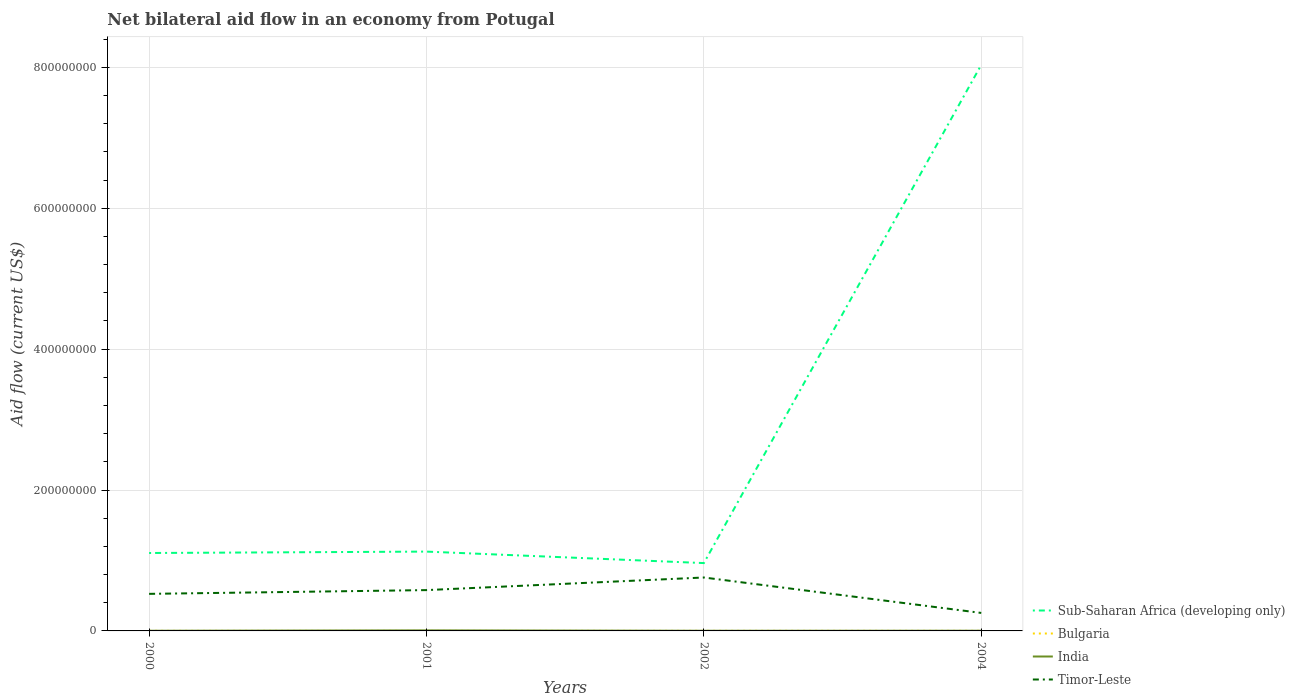How many different coloured lines are there?
Provide a succinct answer. 4. Does the line corresponding to Timor-Leste intersect with the line corresponding to Bulgaria?
Offer a terse response. No. Across all years, what is the maximum net bilateral aid flow in Sub-Saharan Africa (developing only)?
Offer a terse response. 9.63e+07. In which year was the net bilateral aid flow in Sub-Saharan Africa (developing only) maximum?
Keep it short and to the point. 2002. What is the total net bilateral aid flow in India in the graph?
Keep it short and to the point. 0. What is the difference between the highest and the second highest net bilateral aid flow in India?
Keep it short and to the point. 5.40e+05. How many years are there in the graph?
Your answer should be compact. 4. What is the difference between two consecutive major ticks on the Y-axis?
Offer a terse response. 2.00e+08. Are the values on the major ticks of Y-axis written in scientific E-notation?
Offer a terse response. No. Does the graph contain grids?
Your answer should be compact. Yes. How are the legend labels stacked?
Provide a succinct answer. Vertical. What is the title of the graph?
Your answer should be very brief. Net bilateral aid flow in an economy from Potugal. Does "Togo" appear as one of the legend labels in the graph?
Keep it short and to the point. No. What is the label or title of the Y-axis?
Keep it short and to the point. Aid flow (current US$). What is the Aid flow (current US$) of Sub-Saharan Africa (developing only) in 2000?
Keep it short and to the point. 1.11e+08. What is the Aid flow (current US$) of Bulgaria in 2000?
Offer a very short reply. 8.00e+04. What is the Aid flow (current US$) of Timor-Leste in 2000?
Provide a short and direct response. 5.26e+07. What is the Aid flow (current US$) of Sub-Saharan Africa (developing only) in 2001?
Ensure brevity in your answer.  1.13e+08. What is the Aid flow (current US$) in India in 2001?
Ensure brevity in your answer.  7.80e+05. What is the Aid flow (current US$) of Timor-Leste in 2001?
Your response must be concise. 5.80e+07. What is the Aid flow (current US$) of Sub-Saharan Africa (developing only) in 2002?
Your answer should be compact. 9.63e+07. What is the Aid flow (current US$) of Bulgaria in 2002?
Your response must be concise. 8.00e+04. What is the Aid flow (current US$) in Timor-Leste in 2002?
Your answer should be compact. 7.58e+07. What is the Aid flow (current US$) of Sub-Saharan Africa (developing only) in 2004?
Give a very brief answer. 8.04e+08. What is the Aid flow (current US$) of Bulgaria in 2004?
Your answer should be compact. 8.00e+04. What is the Aid flow (current US$) of Timor-Leste in 2004?
Your response must be concise. 2.56e+07. Across all years, what is the maximum Aid flow (current US$) in Sub-Saharan Africa (developing only)?
Offer a terse response. 8.04e+08. Across all years, what is the maximum Aid flow (current US$) in India?
Offer a terse response. 7.80e+05. Across all years, what is the maximum Aid flow (current US$) in Timor-Leste?
Offer a very short reply. 7.58e+07. Across all years, what is the minimum Aid flow (current US$) in Sub-Saharan Africa (developing only)?
Your response must be concise. 9.63e+07. Across all years, what is the minimum Aid flow (current US$) of Timor-Leste?
Your answer should be very brief. 2.56e+07. What is the total Aid flow (current US$) of Sub-Saharan Africa (developing only) in the graph?
Ensure brevity in your answer.  1.12e+09. What is the total Aid flow (current US$) of Bulgaria in the graph?
Make the answer very short. 2.70e+05. What is the total Aid flow (current US$) in India in the graph?
Provide a succinct answer. 1.55e+06. What is the total Aid flow (current US$) of Timor-Leste in the graph?
Give a very brief answer. 2.12e+08. What is the difference between the Aid flow (current US$) of Sub-Saharan Africa (developing only) in 2000 and that in 2001?
Offer a very short reply. -2.00e+06. What is the difference between the Aid flow (current US$) in India in 2000 and that in 2001?
Offer a terse response. -5.40e+05. What is the difference between the Aid flow (current US$) of Timor-Leste in 2000 and that in 2001?
Provide a short and direct response. -5.33e+06. What is the difference between the Aid flow (current US$) of Sub-Saharan Africa (developing only) in 2000 and that in 2002?
Provide a short and direct response. 1.43e+07. What is the difference between the Aid flow (current US$) in Bulgaria in 2000 and that in 2002?
Offer a very short reply. 0. What is the difference between the Aid flow (current US$) of India in 2000 and that in 2002?
Keep it short and to the point. 0. What is the difference between the Aid flow (current US$) in Timor-Leste in 2000 and that in 2002?
Provide a short and direct response. -2.32e+07. What is the difference between the Aid flow (current US$) in Sub-Saharan Africa (developing only) in 2000 and that in 2004?
Your answer should be compact. -6.93e+08. What is the difference between the Aid flow (current US$) of Bulgaria in 2000 and that in 2004?
Your answer should be very brief. 0. What is the difference between the Aid flow (current US$) of Timor-Leste in 2000 and that in 2004?
Offer a terse response. 2.71e+07. What is the difference between the Aid flow (current US$) in Sub-Saharan Africa (developing only) in 2001 and that in 2002?
Provide a succinct answer. 1.63e+07. What is the difference between the Aid flow (current US$) in India in 2001 and that in 2002?
Give a very brief answer. 5.40e+05. What is the difference between the Aid flow (current US$) in Timor-Leste in 2001 and that in 2002?
Give a very brief answer. -1.79e+07. What is the difference between the Aid flow (current US$) in Sub-Saharan Africa (developing only) in 2001 and that in 2004?
Offer a very short reply. -6.91e+08. What is the difference between the Aid flow (current US$) of India in 2001 and that in 2004?
Your answer should be very brief. 4.90e+05. What is the difference between the Aid flow (current US$) in Timor-Leste in 2001 and that in 2004?
Your answer should be compact. 3.24e+07. What is the difference between the Aid flow (current US$) of Sub-Saharan Africa (developing only) in 2002 and that in 2004?
Provide a succinct answer. -7.07e+08. What is the difference between the Aid flow (current US$) in Timor-Leste in 2002 and that in 2004?
Make the answer very short. 5.03e+07. What is the difference between the Aid flow (current US$) of Sub-Saharan Africa (developing only) in 2000 and the Aid flow (current US$) of Bulgaria in 2001?
Keep it short and to the point. 1.11e+08. What is the difference between the Aid flow (current US$) of Sub-Saharan Africa (developing only) in 2000 and the Aid flow (current US$) of India in 2001?
Offer a terse response. 1.10e+08. What is the difference between the Aid flow (current US$) of Sub-Saharan Africa (developing only) in 2000 and the Aid flow (current US$) of Timor-Leste in 2001?
Provide a short and direct response. 5.27e+07. What is the difference between the Aid flow (current US$) of Bulgaria in 2000 and the Aid flow (current US$) of India in 2001?
Make the answer very short. -7.00e+05. What is the difference between the Aid flow (current US$) in Bulgaria in 2000 and the Aid flow (current US$) in Timor-Leste in 2001?
Provide a short and direct response. -5.79e+07. What is the difference between the Aid flow (current US$) in India in 2000 and the Aid flow (current US$) in Timor-Leste in 2001?
Make the answer very short. -5.77e+07. What is the difference between the Aid flow (current US$) in Sub-Saharan Africa (developing only) in 2000 and the Aid flow (current US$) in Bulgaria in 2002?
Your response must be concise. 1.11e+08. What is the difference between the Aid flow (current US$) of Sub-Saharan Africa (developing only) in 2000 and the Aid flow (current US$) of India in 2002?
Provide a succinct answer. 1.10e+08. What is the difference between the Aid flow (current US$) of Sub-Saharan Africa (developing only) in 2000 and the Aid flow (current US$) of Timor-Leste in 2002?
Offer a very short reply. 3.48e+07. What is the difference between the Aid flow (current US$) in Bulgaria in 2000 and the Aid flow (current US$) in India in 2002?
Ensure brevity in your answer.  -1.60e+05. What is the difference between the Aid flow (current US$) of Bulgaria in 2000 and the Aid flow (current US$) of Timor-Leste in 2002?
Provide a short and direct response. -7.58e+07. What is the difference between the Aid flow (current US$) in India in 2000 and the Aid flow (current US$) in Timor-Leste in 2002?
Provide a succinct answer. -7.56e+07. What is the difference between the Aid flow (current US$) of Sub-Saharan Africa (developing only) in 2000 and the Aid flow (current US$) of Bulgaria in 2004?
Provide a succinct answer. 1.11e+08. What is the difference between the Aid flow (current US$) of Sub-Saharan Africa (developing only) in 2000 and the Aid flow (current US$) of India in 2004?
Make the answer very short. 1.10e+08. What is the difference between the Aid flow (current US$) of Sub-Saharan Africa (developing only) in 2000 and the Aid flow (current US$) of Timor-Leste in 2004?
Ensure brevity in your answer.  8.51e+07. What is the difference between the Aid flow (current US$) in Bulgaria in 2000 and the Aid flow (current US$) in Timor-Leste in 2004?
Make the answer very short. -2.55e+07. What is the difference between the Aid flow (current US$) in India in 2000 and the Aid flow (current US$) in Timor-Leste in 2004?
Your answer should be very brief. -2.53e+07. What is the difference between the Aid flow (current US$) in Sub-Saharan Africa (developing only) in 2001 and the Aid flow (current US$) in Bulgaria in 2002?
Your answer should be very brief. 1.13e+08. What is the difference between the Aid flow (current US$) in Sub-Saharan Africa (developing only) in 2001 and the Aid flow (current US$) in India in 2002?
Your response must be concise. 1.12e+08. What is the difference between the Aid flow (current US$) of Sub-Saharan Africa (developing only) in 2001 and the Aid flow (current US$) of Timor-Leste in 2002?
Provide a short and direct response. 3.68e+07. What is the difference between the Aid flow (current US$) of Bulgaria in 2001 and the Aid flow (current US$) of Timor-Leste in 2002?
Provide a succinct answer. -7.58e+07. What is the difference between the Aid flow (current US$) in India in 2001 and the Aid flow (current US$) in Timor-Leste in 2002?
Provide a short and direct response. -7.51e+07. What is the difference between the Aid flow (current US$) in Sub-Saharan Africa (developing only) in 2001 and the Aid flow (current US$) in Bulgaria in 2004?
Offer a terse response. 1.13e+08. What is the difference between the Aid flow (current US$) in Sub-Saharan Africa (developing only) in 2001 and the Aid flow (current US$) in India in 2004?
Provide a succinct answer. 1.12e+08. What is the difference between the Aid flow (current US$) in Sub-Saharan Africa (developing only) in 2001 and the Aid flow (current US$) in Timor-Leste in 2004?
Offer a terse response. 8.71e+07. What is the difference between the Aid flow (current US$) in Bulgaria in 2001 and the Aid flow (current US$) in Timor-Leste in 2004?
Provide a succinct answer. -2.55e+07. What is the difference between the Aid flow (current US$) in India in 2001 and the Aid flow (current US$) in Timor-Leste in 2004?
Ensure brevity in your answer.  -2.48e+07. What is the difference between the Aid flow (current US$) in Sub-Saharan Africa (developing only) in 2002 and the Aid flow (current US$) in Bulgaria in 2004?
Your answer should be very brief. 9.62e+07. What is the difference between the Aid flow (current US$) of Sub-Saharan Africa (developing only) in 2002 and the Aid flow (current US$) of India in 2004?
Your answer should be compact. 9.60e+07. What is the difference between the Aid flow (current US$) in Sub-Saharan Africa (developing only) in 2002 and the Aid flow (current US$) in Timor-Leste in 2004?
Your response must be concise. 7.08e+07. What is the difference between the Aid flow (current US$) in Bulgaria in 2002 and the Aid flow (current US$) in Timor-Leste in 2004?
Keep it short and to the point. -2.55e+07. What is the difference between the Aid flow (current US$) in India in 2002 and the Aid flow (current US$) in Timor-Leste in 2004?
Your answer should be compact. -2.53e+07. What is the average Aid flow (current US$) of Sub-Saharan Africa (developing only) per year?
Your response must be concise. 2.81e+08. What is the average Aid flow (current US$) of Bulgaria per year?
Offer a very short reply. 6.75e+04. What is the average Aid flow (current US$) of India per year?
Your answer should be compact. 3.88e+05. What is the average Aid flow (current US$) in Timor-Leste per year?
Provide a succinct answer. 5.30e+07. In the year 2000, what is the difference between the Aid flow (current US$) in Sub-Saharan Africa (developing only) and Aid flow (current US$) in Bulgaria?
Offer a very short reply. 1.11e+08. In the year 2000, what is the difference between the Aid flow (current US$) of Sub-Saharan Africa (developing only) and Aid flow (current US$) of India?
Provide a short and direct response. 1.10e+08. In the year 2000, what is the difference between the Aid flow (current US$) of Sub-Saharan Africa (developing only) and Aid flow (current US$) of Timor-Leste?
Offer a terse response. 5.80e+07. In the year 2000, what is the difference between the Aid flow (current US$) of Bulgaria and Aid flow (current US$) of India?
Your answer should be very brief. -1.60e+05. In the year 2000, what is the difference between the Aid flow (current US$) of Bulgaria and Aid flow (current US$) of Timor-Leste?
Your answer should be compact. -5.25e+07. In the year 2000, what is the difference between the Aid flow (current US$) in India and Aid flow (current US$) in Timor-Leste?
Offer a very short reply. -5.24e+07. In the year 2001, what is the difference between the Aid flow (current US$) of Sub-Saharan Africa (developing only) and Aid flow (current US$) of Bulgaria?
Offer a very short reply. 1.13e+08. In the year 2001, what is the difference between the Aid flow (current US$) in Sub-Saharan Africa (developing only) and Aid flow (current US$) in India?
Offer a terse response. 1.12e+08. In the year 2001, what is the difference between the Aid flow (current US$) in Sub-Saharan Africa (developing only) and Aid flow (current US$) in Timor-Leste?
Make the answer very short. 5.47e+07. In the year 2001, what is the difference between the Aid flow (current US$) of Bulgaria and Aid flow (current US$) of India?
Give a very brief answer. -7.50e+05. In the year 2001, what is the difference between the Aid flow (current US$) of Bulgaria and Aid flow (current US$) of Timor-Leste?
Your answer should be compact. -5.79e+07. In the year 2001, what is the difference between the Aid flow (current US$) of India and Aid flow (current US$) of Timor-Leste?
Your answer should be very brief. -5.72e+07. In the year 2002, what is the difference between the Aid flow (current US$) in Sub-Saharan Africa (developing only) and Aid flow (current US$) in Bulgaria?
Your response must be concise. 9.62e+07. In the year 2002, what is the difference between the Aid flow (current US$) of Sub-Saharan Africa (developing only) and Aid flow (current US$) of India?
Provide a succinct answer. 9.61e+07. In the year 2002, what is the difference between the Aid flow (current US$) of Sub-Saharan Africa (developing only) and Aid flow (current US$) of Timor-Leste?
Offer a very short reply. 2.05e+07. In the year 2002, what is the difference between the Aid flow (current US$) of Bulgaria and Aid flow (current US$) of Timor-Leste?
Your response must be concise. -7.58e+07. In the year 2002, what is the difference between the Aid flow (current US$) in India and Aid flow (current US$) in Timor-Leste?
Your answer should be compact. -7.56e+07. In the year 2004, what is the difference between the Aid flow (current US$) of Sub-Saharan Africa (developing only) and Aid flow (current US$) of Bulgaria?
Make the answer very short. 8.04e+08. In the year 2004, what is the difference between the Aid flow (current US$) of Sub-Saharan Africa (developing only) and Aid flow (current US$) of India?
Keep it short and to the point. 8.03e+08. In the year 2004, what is the difference between the Aid flow (current US$) in Sub-Saharan Africa (developing only) and Aid flow (current US$) in Timor-Leste?
Provide a succinct answer. 7.78e+08. In the year 2004, what is the difference between the Aid flow (current US$) in Bulgaria and Aid flow (current US$) in India?
Provide a short and direct response. -2.10e+05. In the year 2004, what is the difference between the Aid flow (current US$) of Bulgaria and Aid flow (current US$) of Timor-Leste?
Ensure brevity in your answer.  -2.55e+07. In the year 2004, what is the difference between the Aid flow (current US$) of India and Aid flow (current US$) of Timor-Leste?
Your answer should be very brief. -2.53e+07. What is the ratio of the Aid flow (current US$) of Sub-Saharan Africa (developing only) in 2000 to that in 2001?
Provide a short and direct response. 0.98. What is the ratio of the Aid flow (current US$) of Bulgaria in 2000 to that in 2001?
Offer a very short reply. 2.67. What is the ratio of the Aid flow (current US$) of India in 2000 to that in 2001?
Provide a short and direct response. 0.31. What is the ratio of the Aid flow (current US$) of Timor-Leste in 2000 to that in 2001?
Provide a succinct answer. 0.91. What is the ratio of the Aid flow (current US$) in Sub-Saharan Africa (developing only) in 2000 to that in 2002?
Make the answer very short. 1.15. What is the ratio of the Aid flow (current US$) in Bulgaria in 2000 to that in 2002?
Make the answer very short. 1. What is the ratio of the Aid flow (current US$) in India in 2000 to that in 2002?
Provide a short and direct response. 1. What is the ratio of the Aid flow (current US$) of Timor-Leste in 2000 to that in 2002?
Your answer should be compact. 0.69. What is the ratio of the Aid flow (current US$) in Sub-Saharan Africa (developing only) in 2000 to that in 2004?
Offer a terse response. 0.14. What is the ratio of the Aid flow (current US$) of India in 2000 to that in 2004?
Provide a succinct answer. 0.83. What is the ratio of the Aid flow (current US$) of Timor-Leste in 2000 to that in 2004?
Ensure brevity in your answer.  2.06. What is the ratio of the Aid flow (current US$) in Sub-Saharan Africa (developing only) in 2001 to that in 2002?
Ensure brevity in your answer.  1.17. What is the ratio of the Aid flow (current US$) in Timor-Leste in 2001 to that in 2002?
Give a very brief answer. 0.76. What is the ratio of the Aid flow (current US$) of Sub-Saharan Africa (developing only) in 2001 to that in 2004?
Keep it short and to the point. 0.14. What is the ratio of the Aid flow (current US$) of India in 2001 to that in 2004?
Ensure brevity in your answer.  2.69. What is the ratio of the Aid flow (current US$) in Timor-Leste in 2001 to that in 2004?
Make the answer very short. 2.27. What is the ratio of the Aid flow (current US$) in Sub-Saharan Africa (developing only) in 2002 to that in 2004?
Your response must be concise. 0.12. What is the ratio of the Aid flow (current US$) of India in 2002 to that in 2004?
Your response must be concise. 0.83. What is the ratio of the Aid flow (current US$) of Timor-Leste in 2002 to that in 2004?
Offer a terse response. 2.97. What is the difference between the highest and the second highest Aid flow (current US$) of Sub-Saharan Africa (developing only)?
Provide a succinct answer. 6.91e+08. What is the difference between the highest and the second highest Aid flow (current US$) of Bulgaria?
Your answer should be compact. 0. What is the difference between the highest and the second highest Aid flow (current US$) of India?
Offer a very short reply. 4.90e+05. What is the difference between the highest and the second highest Aid flow (current US$) of Timor-Leste?
Provide a short and direct response. 1.79e+07. What is the difference between the highest and the lowest Aid flow (current US$) of Sub-Saharan Africa (developing only)?
Your answer should be compact. 7.07e+08. What is the difference between the highest and the lowest Aid flow (current US$) of India?
Offer a terse response. 5.40e+05. What is the difference between the highest and the lowest Aid flow (current US$) of Timor-Leste?
Give a very brief answer. 5.03e+07. 